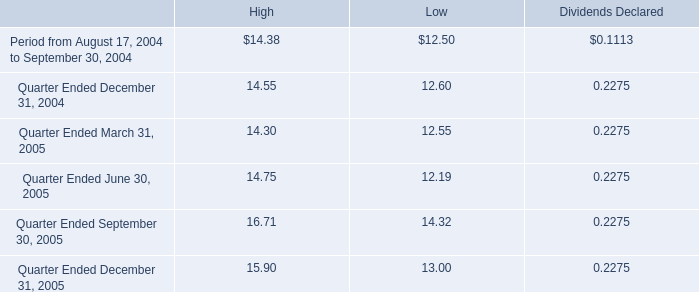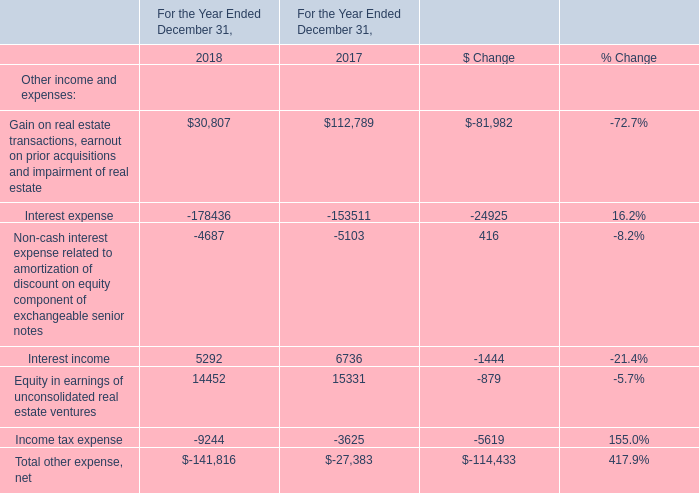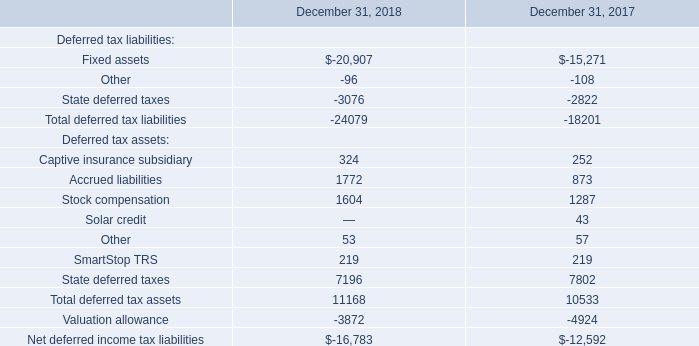Does interest income keeps increasing each year between 2017 and 2018? 
Answer: No. 